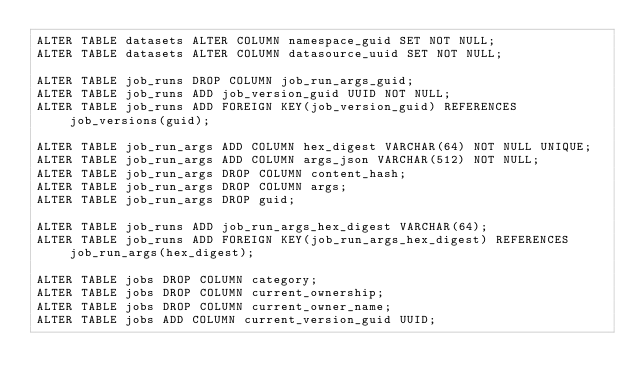Convert code to text. <code><loc_0><loc_0><loc_500><loc_500><_SQL_>ALTER TABLE datasets ALTER COLUMN namespace_guid SET NOT NULL;
ALTER TABLE datasets ALTER COLUMN datasource_uuid SET NOT NULL;

ALTER TABLE job_runs DROP COLUMN job_run_args_guid;
ALTER TABLE job_runs ADD job_version_guid UUID NOT NULL;
ALTER TABLE job_runs ADD FOREIGN KEY(job_version_guid) REFERENCES job_versions(guid);

ALTER TABLE job_run_args ADD COLUMN hex_digest VARCHAR(64) NOT NULL UNIQUE;
ALTER TABLE job_run_args ADD COLUMN args_json VARCHAR(512) NOT NULL;
ALTER TABLE job_run_args DROP COLUMN content_hash;
ALTER TABLE job_run_args DROP COLUMN args;
ALTER TABLE job_run_args DROP guid;

ALTER TABLE job_runs ADD job_run_args_hex_digest VARCHAR(64);
ALTER TABLE job_runs ADD FOREIGN KEY(job_run_args_hex_digest) REFERENCES job_run_args(hex_digest);

ALTER TABLE jobs DROP COLUMN category;
ALTER TABLE jobs DROP COLUMN current_ownership;
ALTER TABLE jobs DROP COLUMN current_owner_name;
ALTER TABLE jobs ADD COLUMN current_version_guid UUID;</code> 